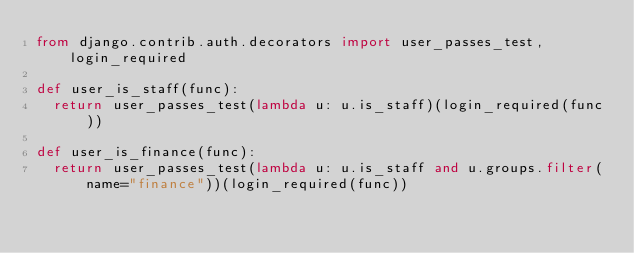Convert code to text. <code><loc_0><loc_0><loc_500><loc_500><_Python_>from django.contrib.auth.decorators import user_passes_test, login_required

def user_is_staff(func):
	return user_passes_test(lambda u: u.is_staff)(login_required(func))

def user_is_finance(func):
	return user_passes_test(lambda u: u.is_staff and u.groups.filter(name="finance"))(login_required(func))
</code> 